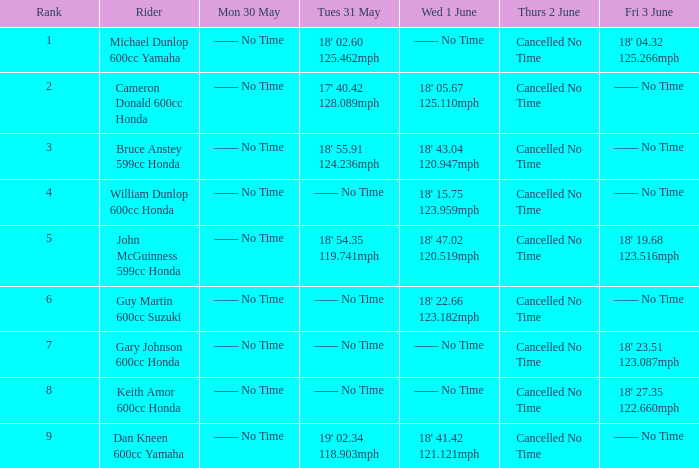What is the rank of the rider whose Tues 31 May time was 19' 02.34 118.903mph? 9.0. 